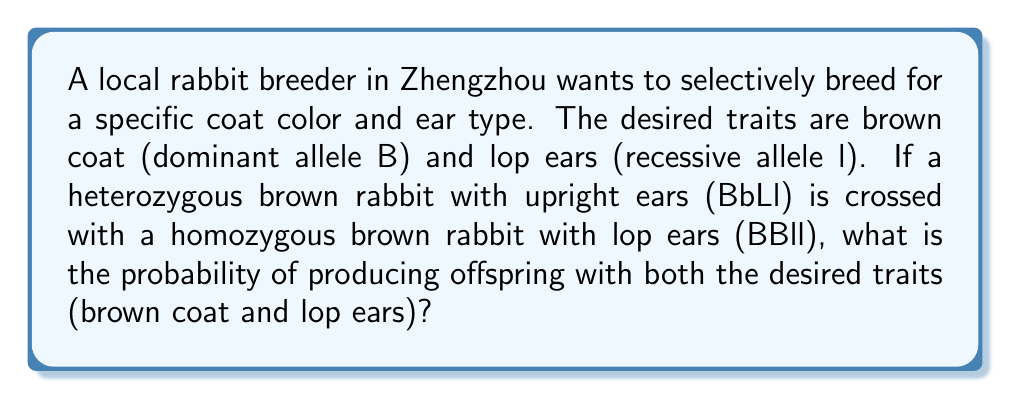What is the answer to this math problem? Let's approach this step-by-step:

1) First, let's identify the genotypes:
   Parent 1 (P1): BbLl (heterozygous brown, heterozygous upright ears)
   Parent 2 (P2): BBll (homozygous brown, homozygous lop ears)

2) Now, let's determine the possible gametes:
   P1 can produce: BL, Bl, bL, bl
   P2 can only produce: Bl

3) Let's create a Punnett square to visualize the possible offspring:

   $$\begin{array}{c|c|c|c|c}
     & BL & Bl & bL & bl \\
   \hline
   Bl & BBLl & BBll & BbLl & Bbll \\
   \end{array}$$

4) We're looking for offspring with brown coat (B_) and lop ears (ll).
   From the Punnett square, we can see that BBll and Bbll meet these criteria.

5) To calculate the probability:
   - BBll appears in 1 out of 4 outcomes
   - Bbll appears in 1 out of 4 outcomes

6) Therefore, the total probability is:
   $$P(\text{brown coat and lop ears}) = \frac{1}{4} + \frac{1}{4} = \frac{1}{2} = 0.5 = 50\%$$
Answer: $\frac{1}{2}$ or $0.5$ or $50\%$ 